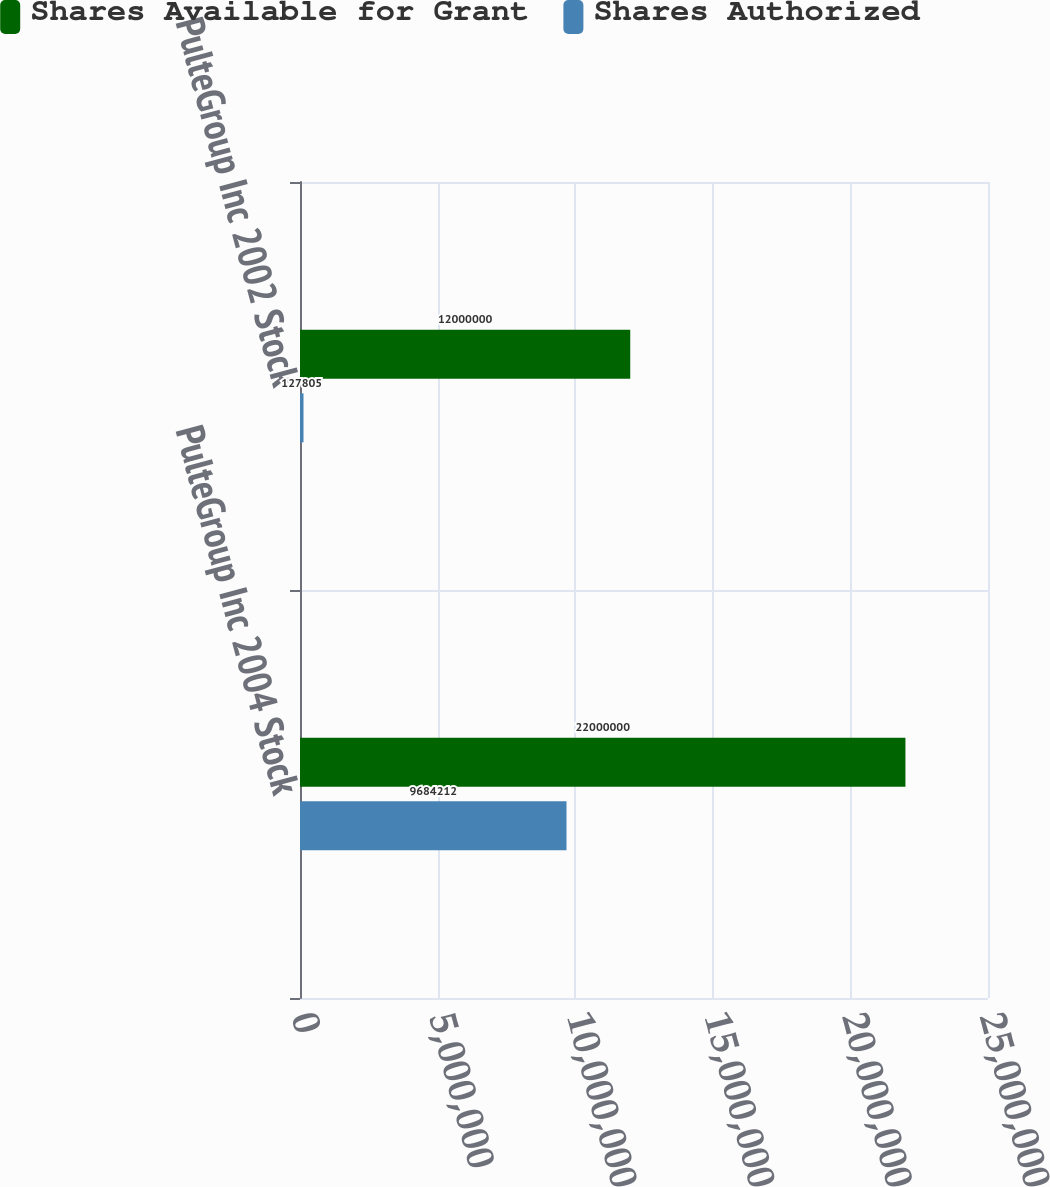Convert chart to OTSL. <chart><loc_0><loc_0><loc_500><loc_500><stacked_bar_chart><ecel><fcel>PulteGroup Inc 2004 Stock<fcel>PulteGroup Inc 2002 Stock<nl><fcel>Shares Available for Grant<fcel>2.2e+07<fcel>1.2e+07<nl><fcel>Shares Authorized<fcel>9.68421e+06<fcel>127805<nl></chart> 